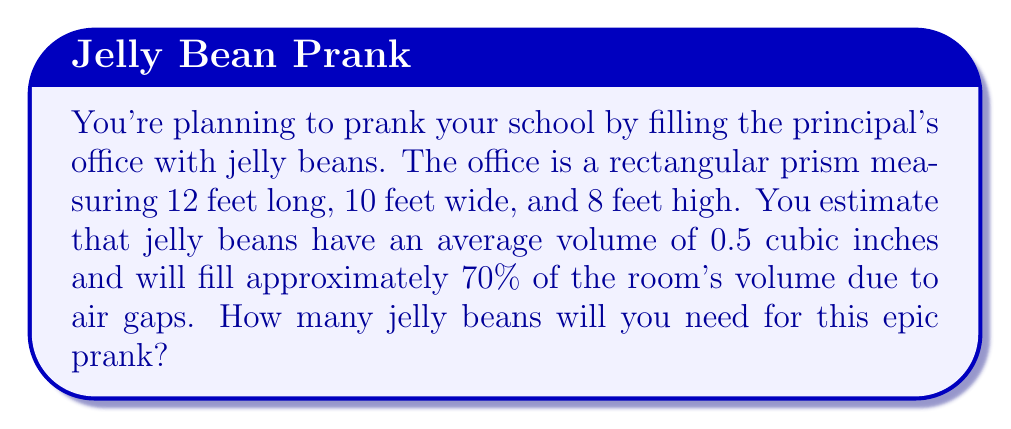What is the answer to this math problem? Let's approach this problem step-by-step:

1) First, calculate the volume of the principal's office:
   $$V_{office} = 12 \text{ ft} \times 10 \text{ ft} \times 8 \text{ ft} = 960 \text{ ft}^3$$

2) Convert the office volume to cubic inches:
   $$960 \text{ ft}^3 \times (12 \text{ in}/\text{ft})^3 = 1,658,880 \text{ in}^3$$

3) Calculate the volume to be filled with jelly beans (70% of the total volume):
   $$V_{filled} = 1,658,880 \text{ in}^3 \times 0.70 = 1,161,216 \text{ in}^3$$

4) Calculate the number of jelly beans needed:
   $$N_{jellybeans} = \frac{V_{filled}}{V_{jellybean}} = \frac{1,161,216 \text{ in}^3}{0.5 \text{ in}^3/\text{jellybean}}$$

5) Simplify and round to the nearest whole number:
   $$N_{jellybeans} = 2,322,432 \text{ jellybeans}$$

Therefore, you'll need approximately 2,322,432 jelly beans for this prank.
Answer: 2,322,432 jelly beans 